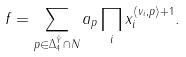<formula> <loc_0><loc_0><loc_500><loc_500>f = \sum _ { p \in \Delta ^ { \tilde { Y } } _ { 4 } \cap N } a _ { p } \prod _ { i } x _ { i } ^ { \langle v _ { i } , p \rangle + 1 } .</formula> 